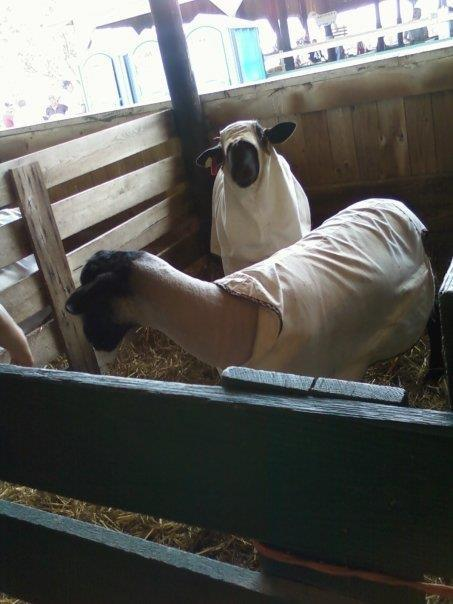What are the animals near? fence 